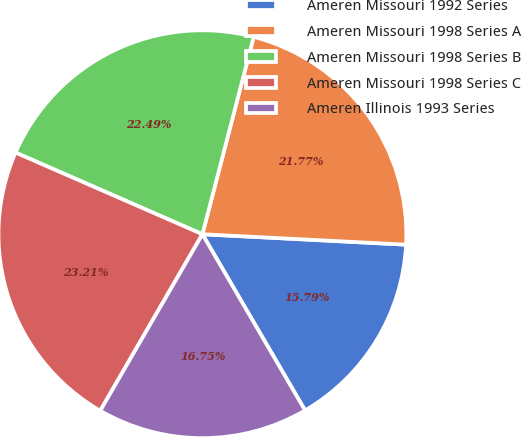Convert chart to OTSL. <chart><loc_0><loc_0><loc_500><loc_500><pie_chart><fcel>Ameren Missouri 1992 Series<fcel>Ameren Missouri 1998 Series A<fcel>Ameren Missouri 1998 Series B<fcel>Ameren Missouri 1998 Series C<fcel>Ameren Illinois 1993 Series<nl><fcel>15.79%<fcel>21.77%<fcel>22.49%<fcel>23.21%<fcel>16.75%<nl></chart> 